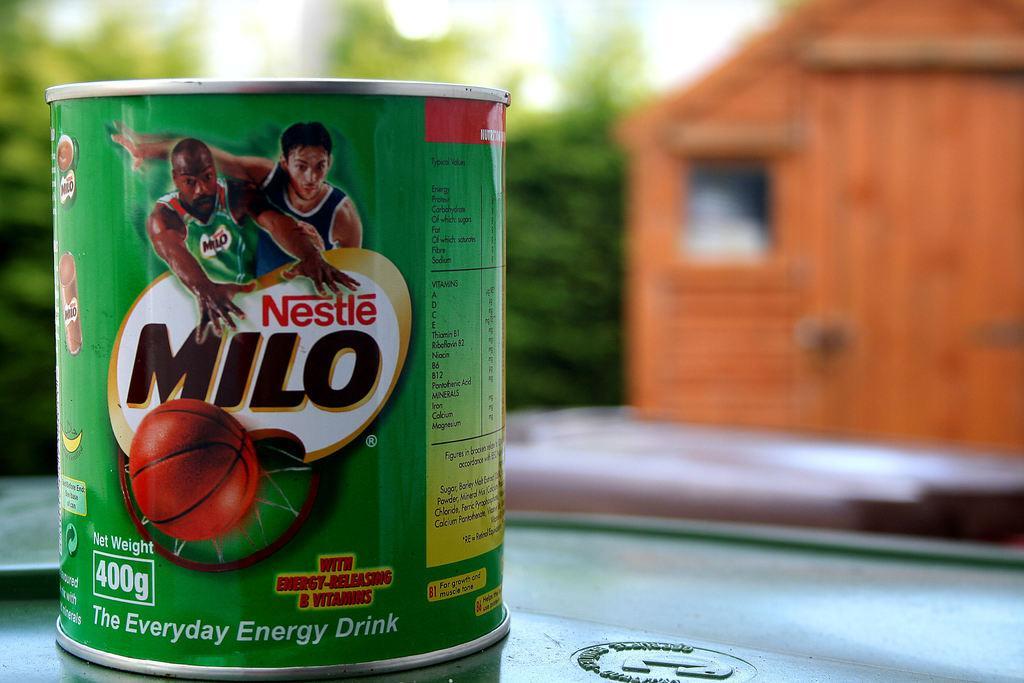How would you summarize this image in a sentence or two? In this image we can see a tin with some text and picture and the tin is placed on a surface which looks like a table and in the background, we can see some trees and the image is blurred. 